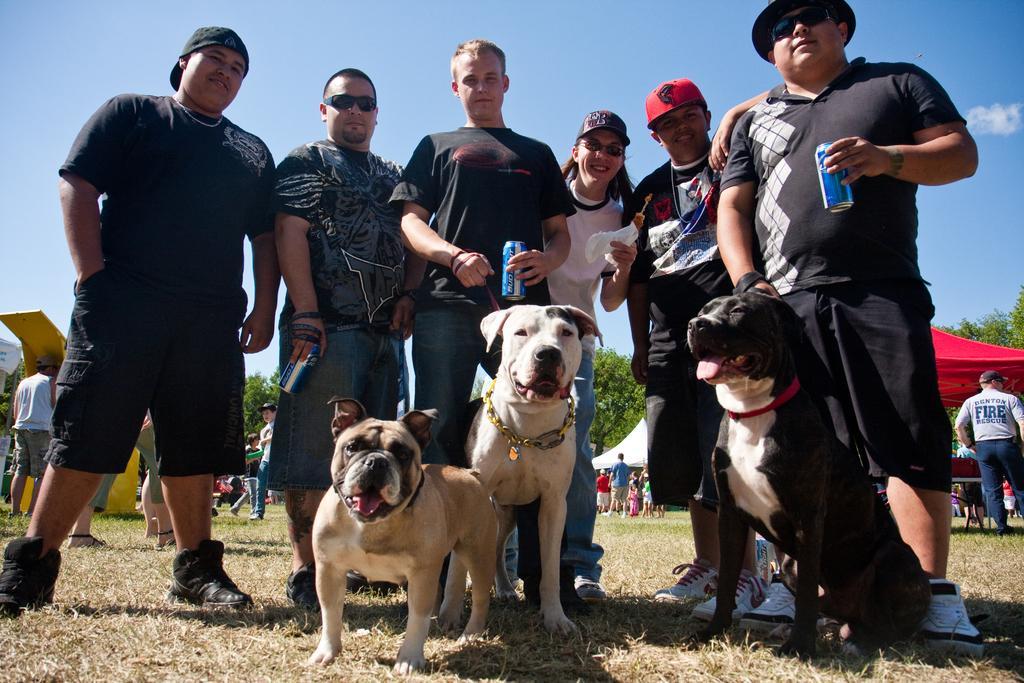In one or two sentences, can you explain what this image depicts? In this image consist of a group of people standing in front of the dogs and on the grass and back side i can see there is sky and there is a tent and on the tent there are the persons visible and some trees visible on the background of the image. 